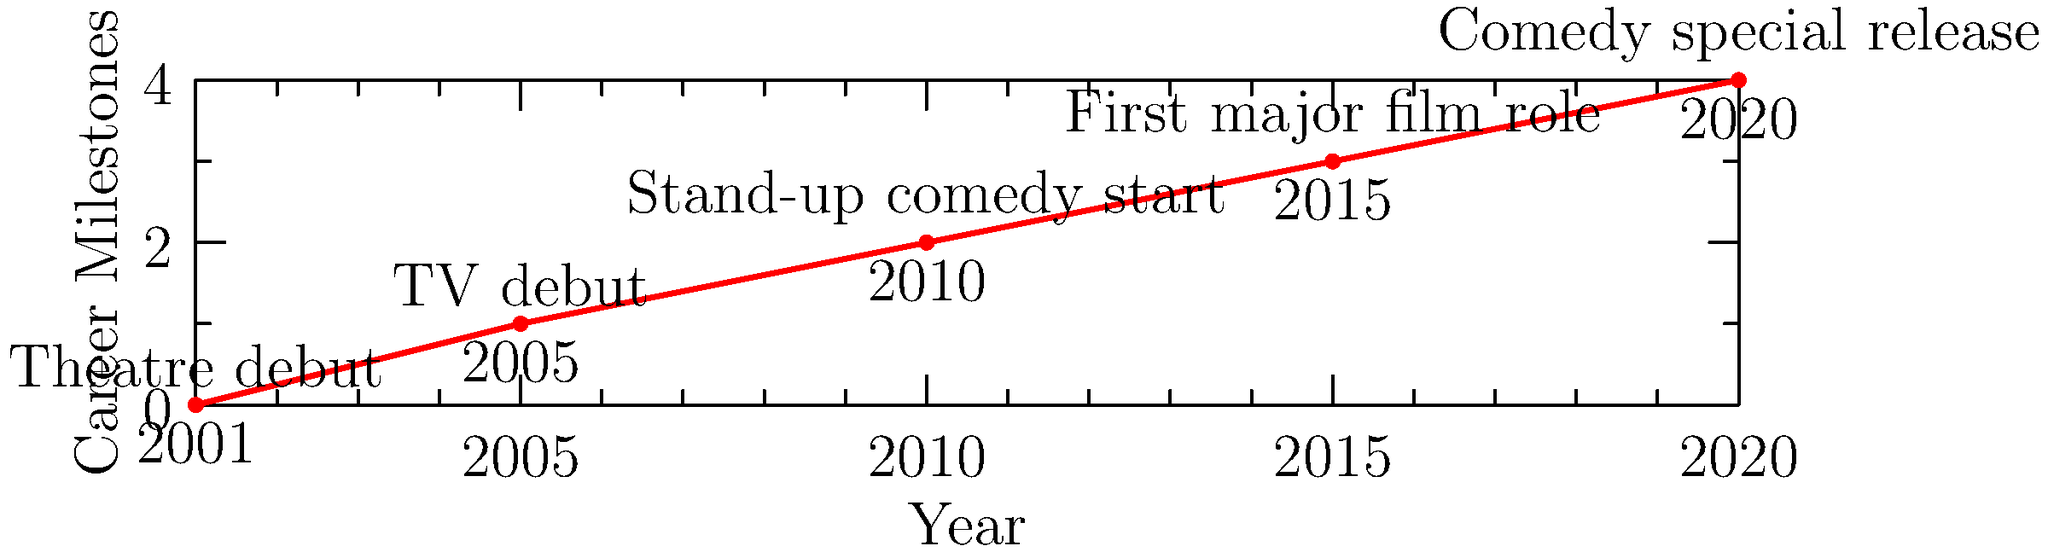Based on the timeline of Amelia Crowley's career, in which year did she begin her journey in stand-up comedy? To answer this question, we need to analyze the timeline graph of Amelia Crowley's career:

1. The graph shows five significant milestones in Crowley's career from 2001 to 2020.
2. Each point on the timeline represents a different career achievement.
3. The milestones are labeled chronologically:
   - 2001: Theatre debut
   - 2005: TV debut
   - 2010: Stand-up comedy start
   - 2015: First major film role
   - 2020: Comedy special release
4. The question specifically asks about when she began her journey in stand-up comedy.
5. Looking at the timeline, we can see that "Stand-up comedy start" is associated with the year 2010.

Therefore, based on the information provided in the timeline, Amelia Crowley began her journey in stand-up comedy in 2010.
Answer: 2010 